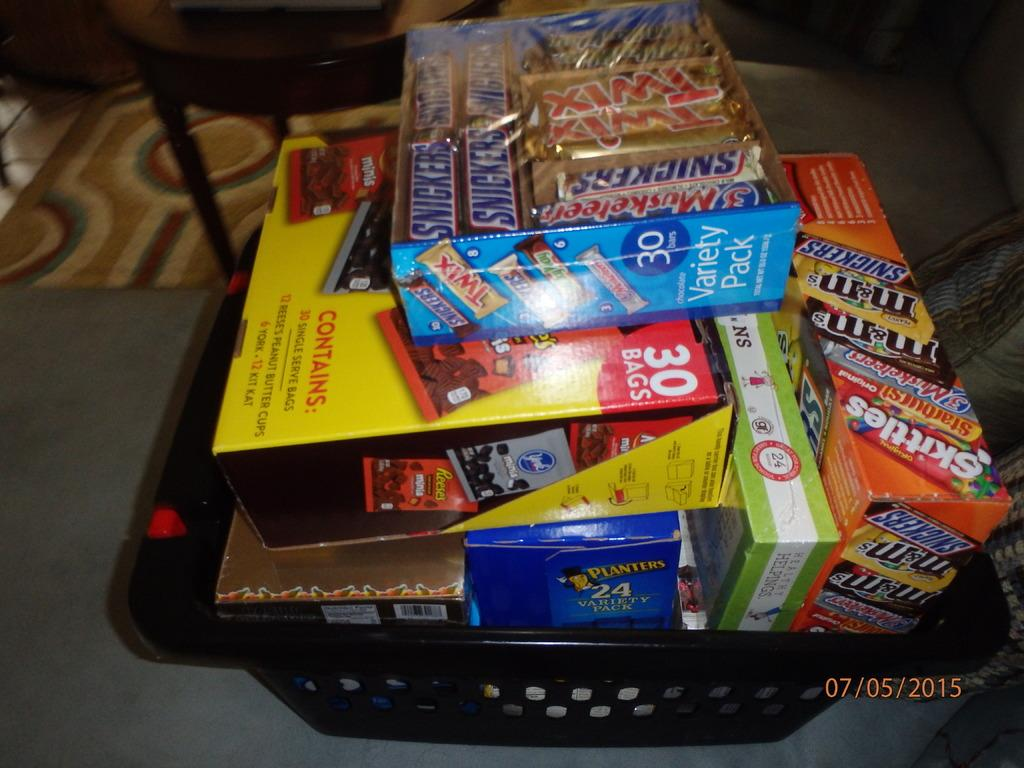<image>
Write a terse but informative summary of the picture. A basket filled with snacks and candy such as twix, snickers, and skittles. 